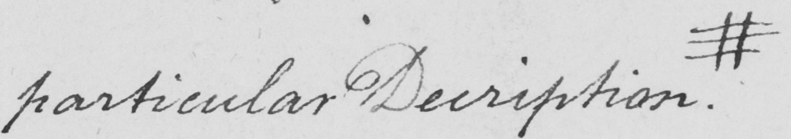What text is written in this handwritten line? particular Description  . # 